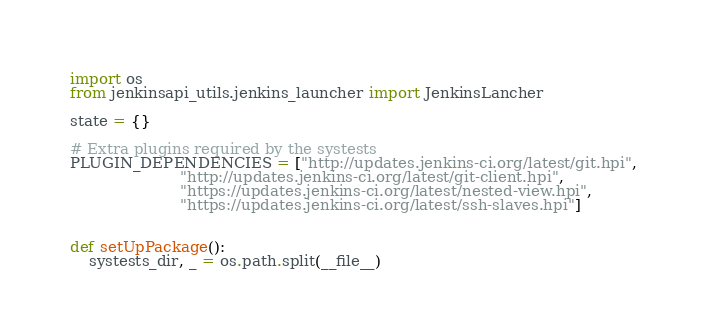Convert code to text. <code><loc_0><loc_0><loc_500><loc_500><_Python_>import os
from jenkinsapi_utils.jenkins_launcher import JenkinsLancher

state = {}

# Extra plugins required by the systests
PLUGIN_DEPENDENCIES = ["http://updates.jenkins-ci.org/latest/git.hpi",
                       "http://updates.jenkins-ci.org/latest/git-client.hpi",
                       "https://updates.jenkins-ci.org/latest/nested-view.hpi",
                       "https://updates.jenkins-ci.org/latest/ssh-slaves.hpi"]


def setUpPackage():
    systests_dir, _ = os.path.split(__file__)</code> 